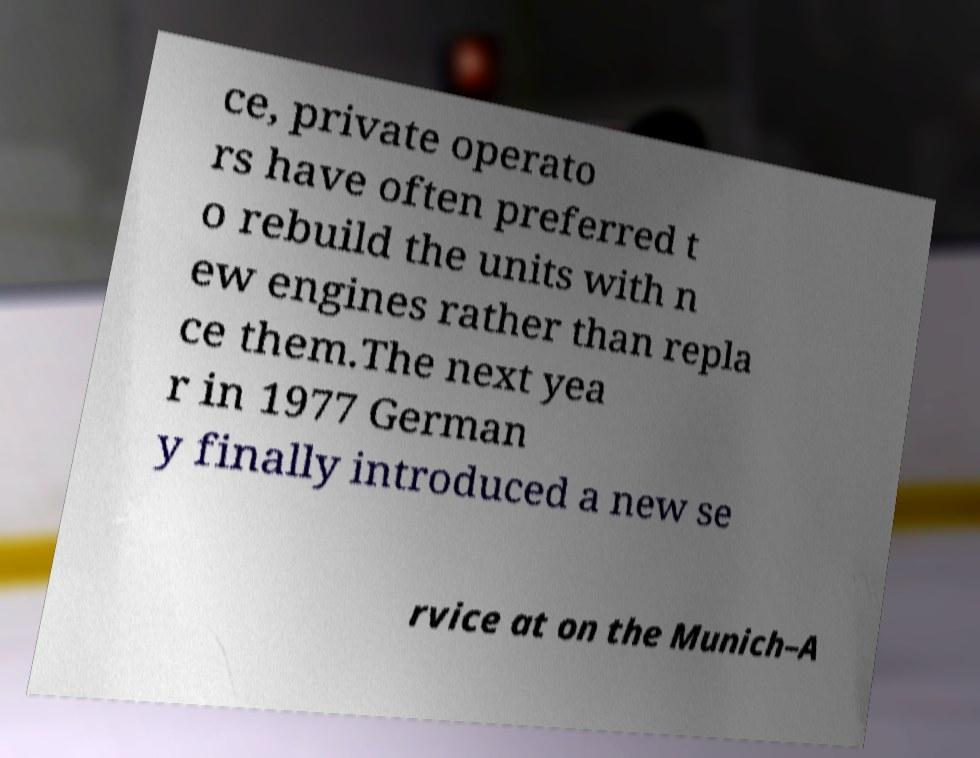Can you accurately transcribe the text from the provided image for me? ce, private operato rs have often preferred t o rebuild the units with n ew engines rather than repla ce them.The next yea r in 1977 German y finally introduced a new se rvice at on the Munich–A 